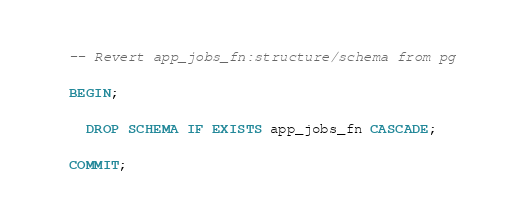Convert code to text. <code><loc_0><loc_0><loc_500><loc_500><_SQL_>-- Revert app_jobs_fn:structure/schema from pg

BEGIN;

  DROP SCHEMA IF EXISTS app_jobs_fn CASCADE;

COMMIT;
</code> 